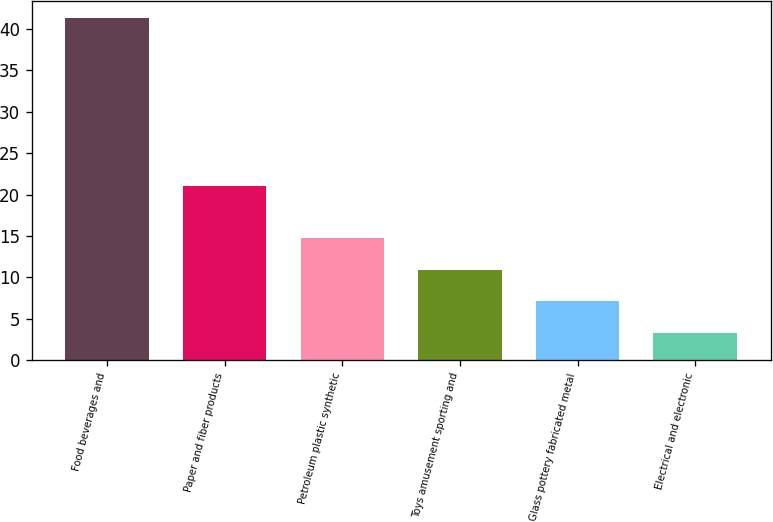<chart> <loc_0><loc_0><loc_500><loc_500><bar_chart><fcel>Food beverages and<fcel>Paper and fiber products<fcel>Petroleum plastic synthetic<fcel>Toys amusement sporting and<fcel>Glass pottery fabricated metal<fcel>Electrical and electronic<nl><fcel>41.3<fcel>21<fcel>14.7<fcel>10.9<fcel>7.1<fcel>3.3<nl></chart> 